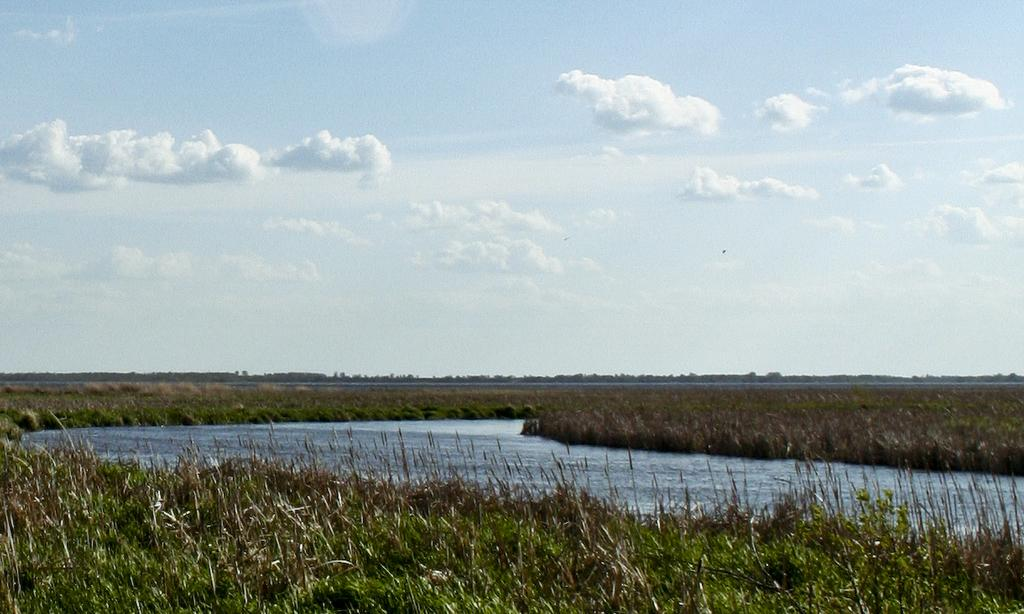What type of living organisms can be seen in the image? Plants can be seen in the image. What is the primary element visible in the image? There is water visible in the image. What can be seen in the background of the image? There are trees and clouds visible in the background of the image. What type of furniture can be seen in the image? There is no furniture present in the image. How does the water pull the plants towards it in the image? The water does not pull the plants towards it in the image; the plants are stationary. 